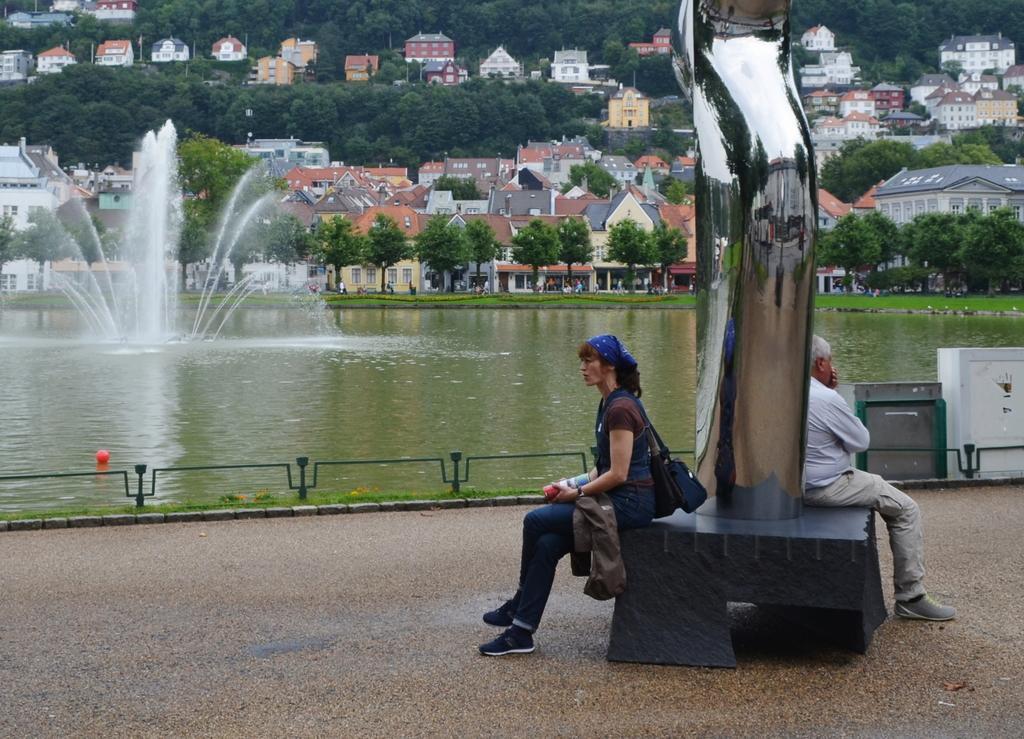How would you summarize this image in a sentence or two? In this image we can see two people sitting and there is a sculpture. We can see a fountain and there is a water. In the background there are trees and sheds. 